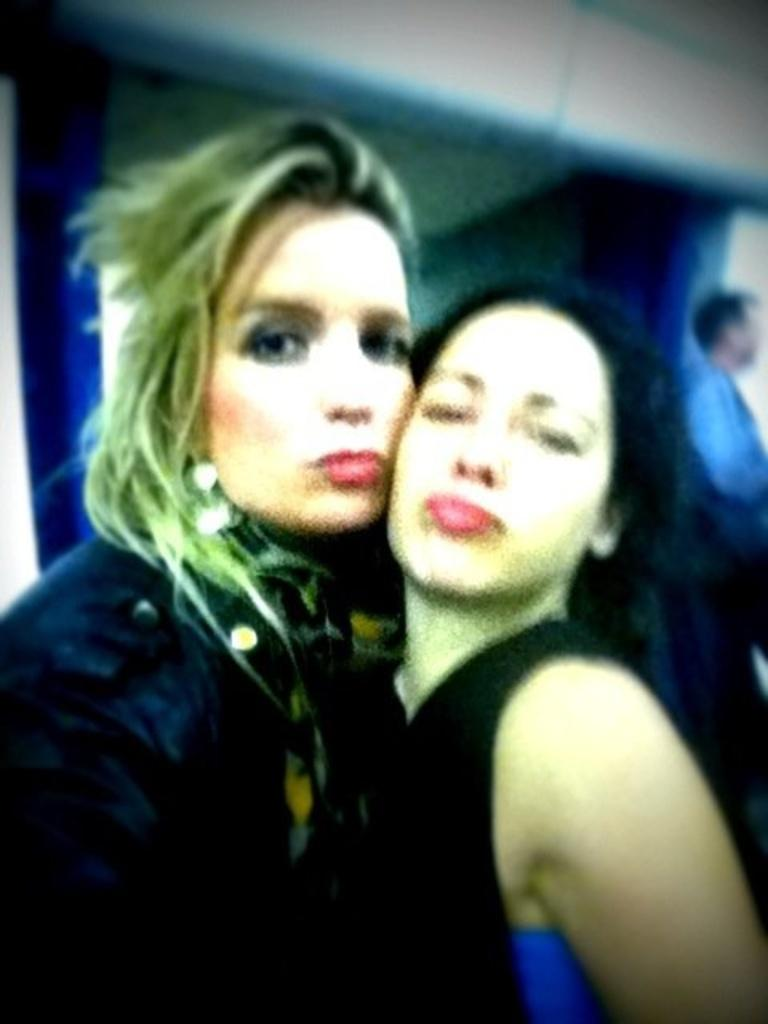Who are the main subjects in the image? There are two ladies in the center of the image. Is there anyone else present in the image? Yes, there is a man standing on the right side of the image. What can be seen in the background of the image? There is a wall in the background of the image. What type of bear can be seen holding a drink in the image? There is no bear or drink present in the image. How many roses are visible in the image? There are no roses visible in the image. 